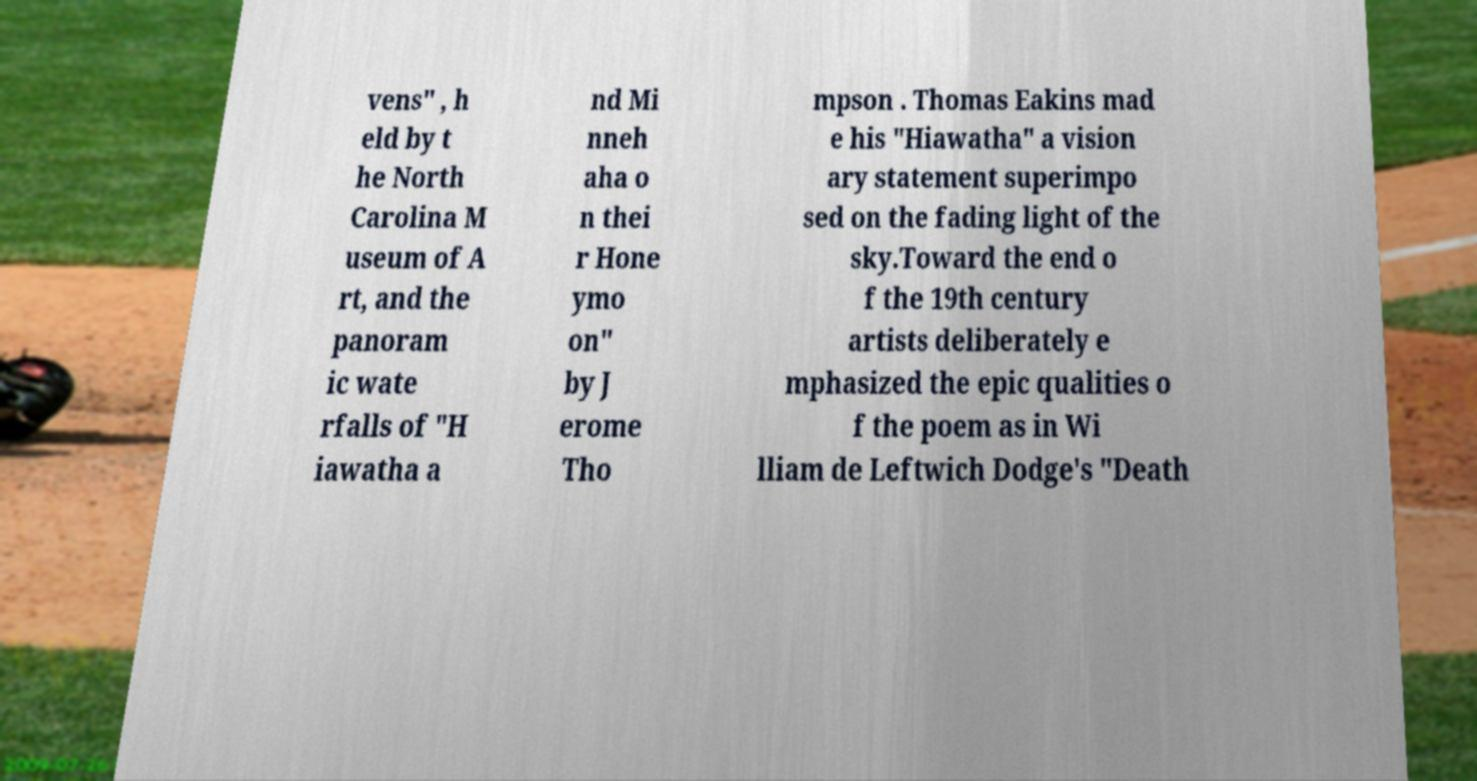Can you read and provide the text displayed in the image?This photo seems to have some interesting text. Can you extract and type it out for me? vens" , h eld by t he North Carolina M useum of A rt, and the panoram ic wate rfalls of "H iawatha a nd Mi nneh aha o n thei r Hone ymo on" by J erome Tho mpson . Thomas Eakins mad e his "Hiawatha" a vision ary statement superimpo sed on the fading light of the sky.Toward the end o f the 19th century artists deliberately e mphasized the epic qualities o f the poem as in Wi lliam de Leftwich Dodge's "Death 